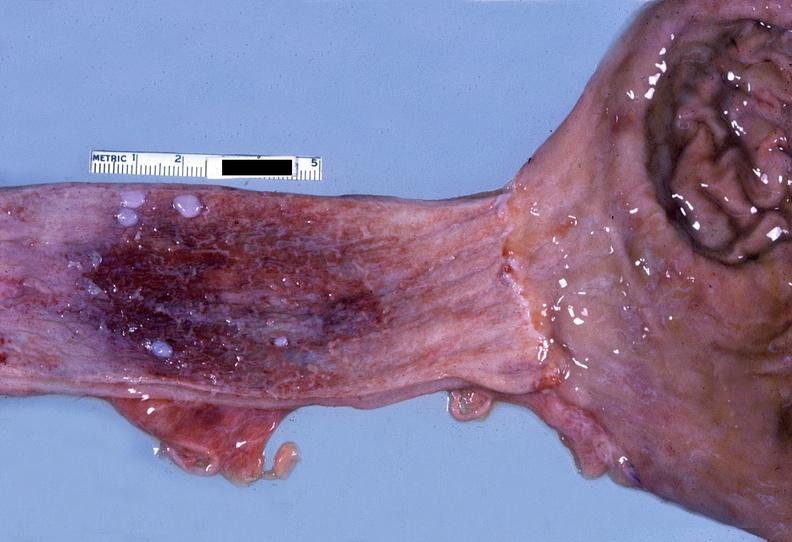what is present?
Answer the question using a single word or phrase. Gastrointestinal 